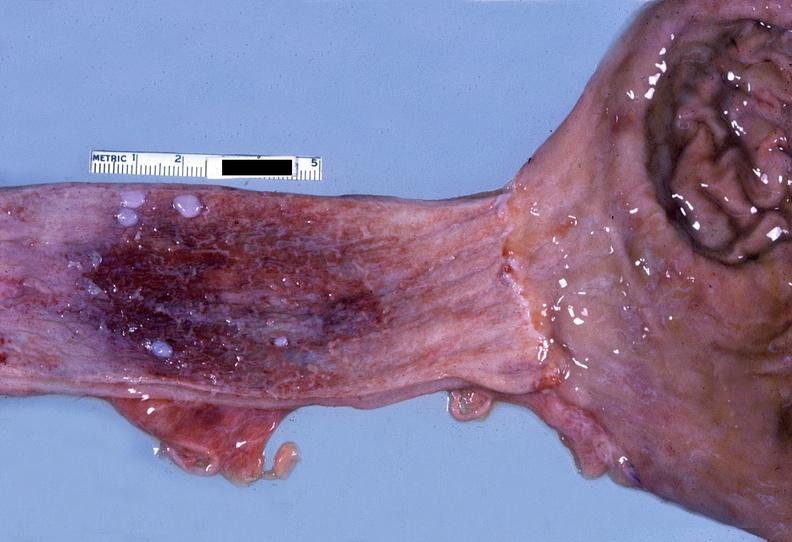what is present?
Answer the question using a single word or phrase. Gastrointestinal 